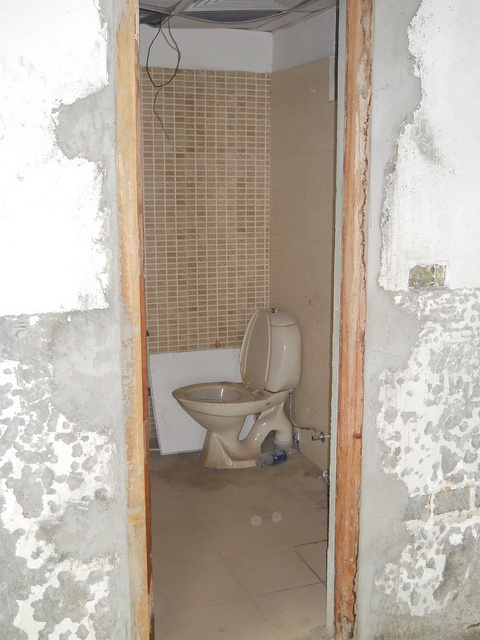Describe the objects in this image and their specific colors. I can see toilet in white, gray, and darkgray tones and bottle in white, gray, and black tones in this image. 